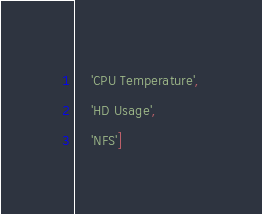Convert code to text. <code><loc_0><loc_0><loc_500><loc_500><_YAML_>    'CPU Temperature',
    'HD Usage',
    'NFS']</code> 